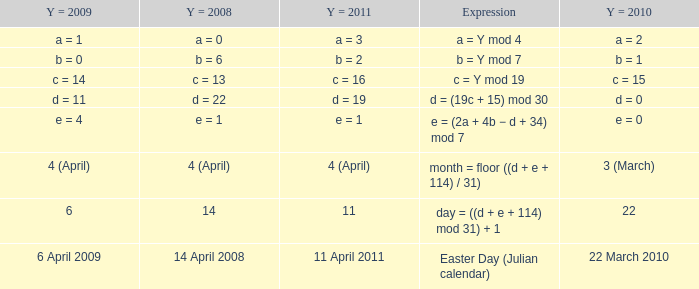What is the y = 2008 when y = 2011 is a = 3? A = 0. 